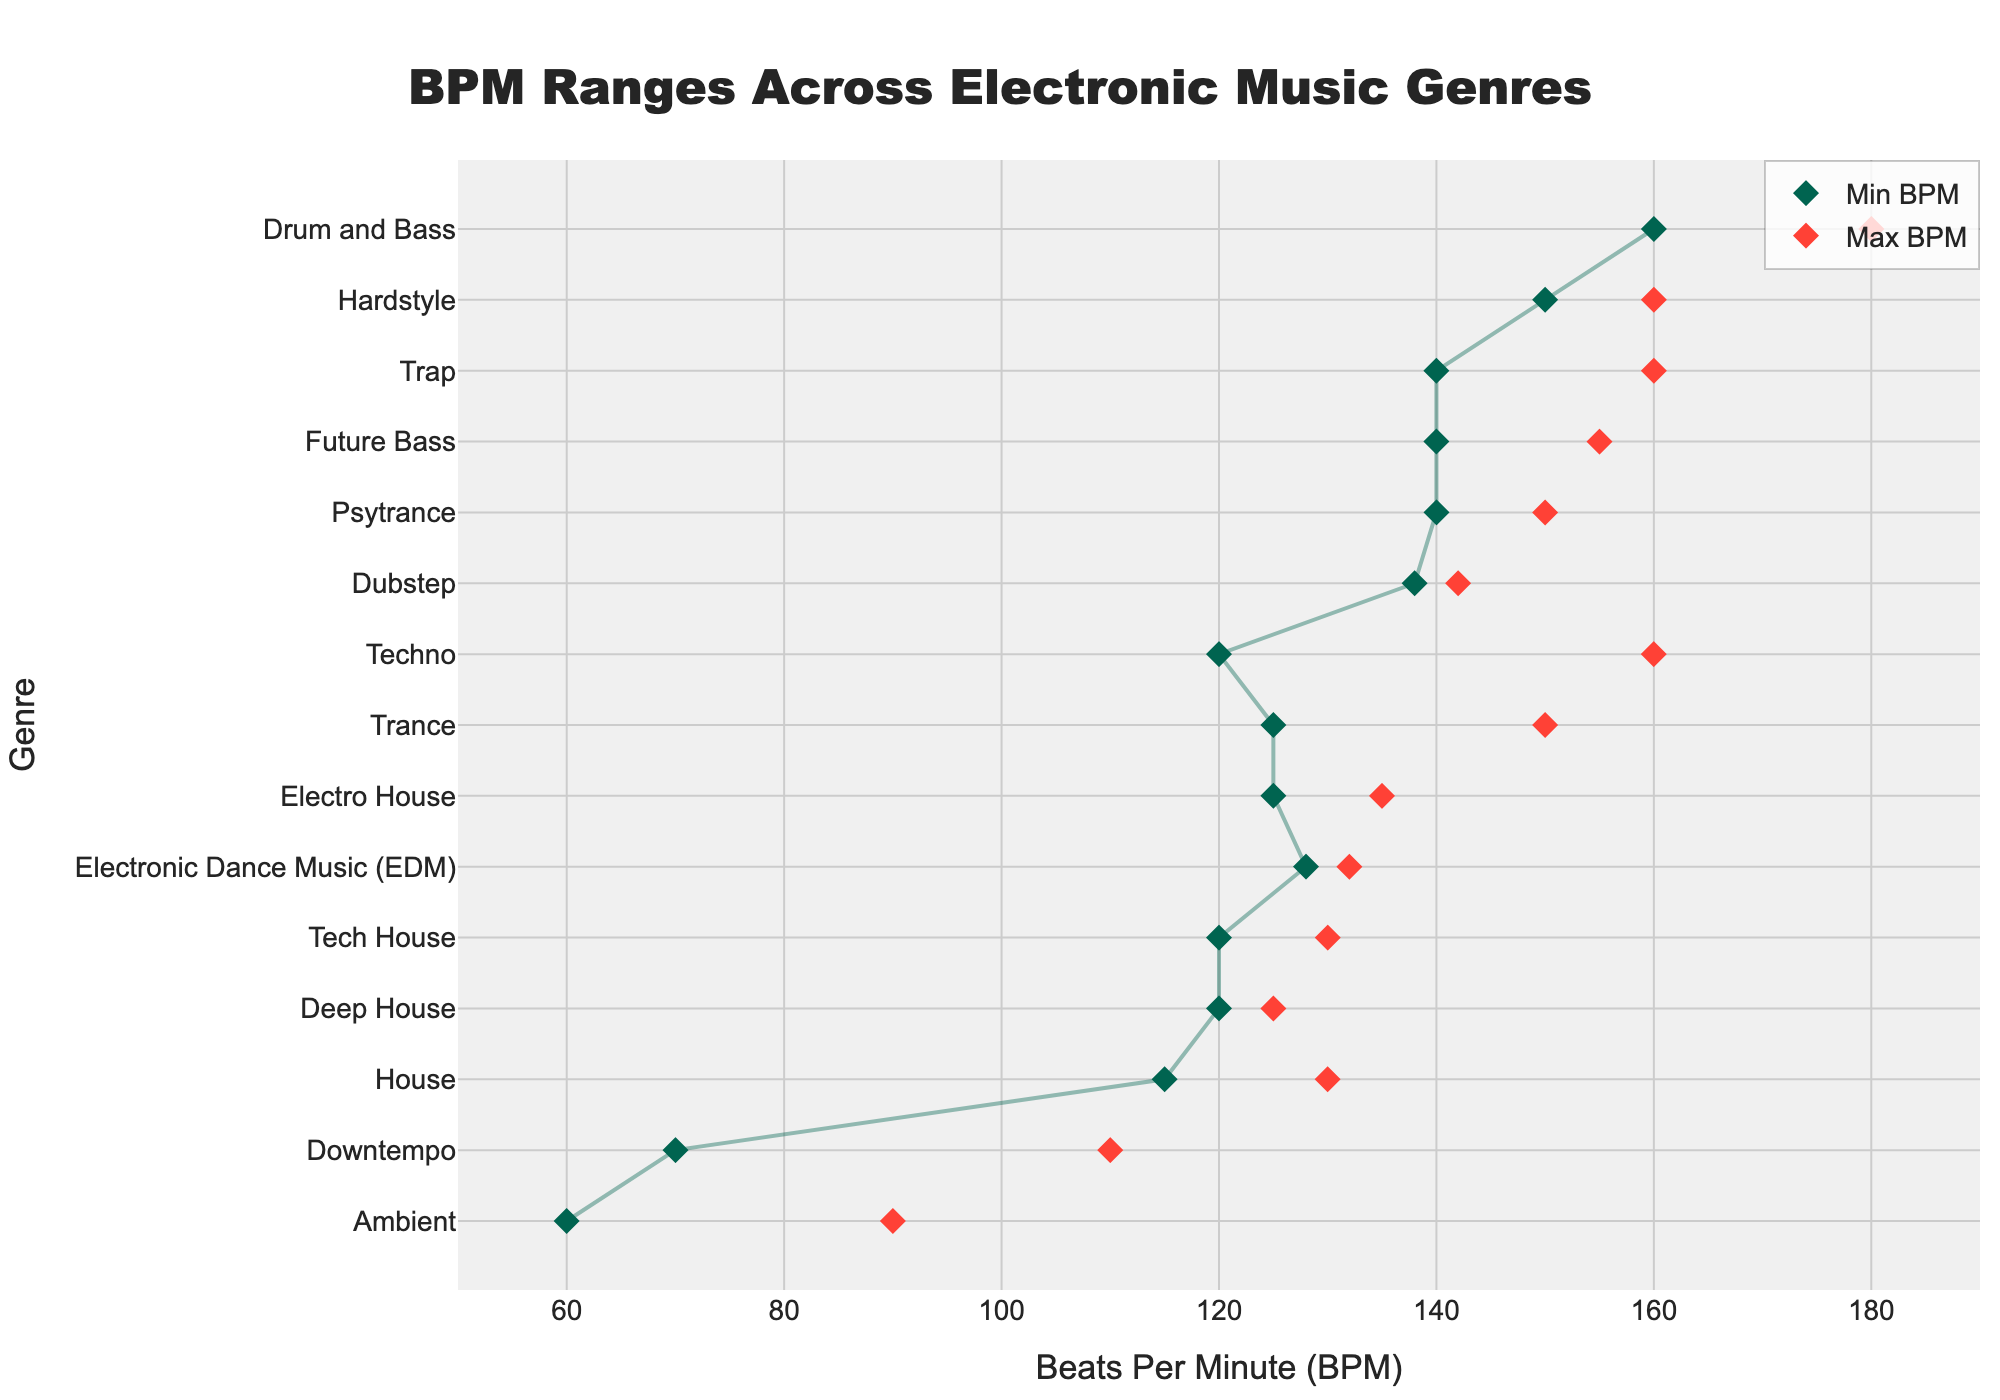What's the range of BPM for Drum and Bass? To find the range, subtract the minimum BPM from the maximum BPM for Drum and Bass. The min BPM is 160, and the max BPM is 180. So, 180 - 160 = 20.
Answer: 20 Which genre has the lowest minimum BPM? The genre with the lowest minimum BPM can be identified by looking at the leftmost diamond marker. Ambient has the lowest minimum BPM of 60.
Answer: Ambient What is the average BPM range for Trance? The average BPM can be calculated by adding the min and max BPM for Trance and then dividing by 2. So, (125 + 150) / 2 = 137.5.
Answer: 137.5 Which genres have a BPM range extending up to or beyond 160 BPM? Identify genres with a max BPM of 160 or more. These genres are Techno, Drum and Bass, Hardstyle, and Trap.
Answer: Techno, Drum and Bass, Hardstyle, Trap How does the BPM range of House compare to that of Tech House? The BPM range of House is from 115 to 130, whereas the BPM range of Tech House is from 120 to 130. Tech House has a narrower range with a higher minimum BPM than House.
Answer: Tech House has a narrower range with a higher minimum BPM Which genre has the widest BPM range? The widest range can be found by checking the length of lines representing each genre. Ambient has the widest BPM range, from 60 to 90, with a range of 30 BPM.
Answer: Ambient What's the BPM range for Downtempo music? Downtempo's BPM range extends from 70 to 110. The range can be calculated as 110 - 70 = 40.
Answer: 40 Is there any genre with a fixed BPM range without any variation? A fixed BPM range means the min and max BPM are the same. No genres in this plot have a completely fixed BPM range.
Answer: No Which genre has the closest BPM range to Electro House? Electro House ranges from 125 to 135 BPM. Tech House ranges from 120 to 130 BPM and is the closest in range to Electro House.
Answer: Tech House Order the genres from the lowest to the highest average BPM. To order, calculate (min BPM + max BPM) / 2 for each genre and then sort accordingly:
Ambient: 75, Downtempo: 90, House: 122.5, Deep House: 122.5, Tech House: 125, Electro House: 130, Trance: 137.5, EDM: 130, Dubstep: 140, Future Bass: 147.5, Psytrance: 145, Techno: 140, Trap: 150, Drum and Bass: 170, Hardstyle: 155.
Answer: Ambient, Downtempo, House, Deep House, Tech House, Electro House, EDM, Trance, Dubstep, Future Bass, Psytrance, Techno, Trap, Hardstyle, Drum and Bass 